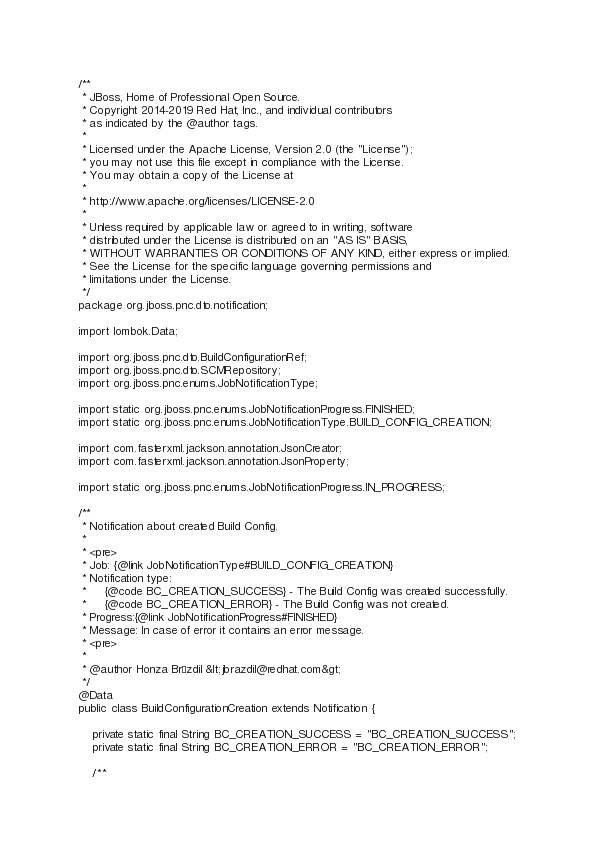Convert code to text. <code><loc_0><loc_0><loc_500><loc_500><_Java_>/**
 * JBoss, Home of Professional Open Source.
 * Copyright 2014-2019 Red Hat, Inc., and individual contributors
 * as indicated by the @author tags.
 *
 * Licensed under the Apache License, Version 2.0 (the "License");
 * you may not use this file except in compliance with the License.
 * You may obtain a copy of the License at
 *
 * http://www.apache.org/licenses/LICENSE-2.0
 *
 * Unless required by applicable law or agreed to in writing, software
 * distributed under the License is distributed on an "AS IS" BASIS,
 * WITHOUT WARRANTIES OR CONDITIONS OF ANY KIND, either express or implied.
 * See the License for the specific language governing permissions and
 * limitations under the License.
 */
package org.jboss.pnc.dto.notification;

import lombok.Data;

import org.jboss.pnc.dto.BuildConfigurationRef;
import org.jboss.pnc.dto.SCMRepository;
import org.jboss.pnc.enums.JobNotificationType;

import static org.jboss.pnc.enums.JobNotificationProgress.FINISHED;
import static org.jboss.pnc.enums.JobNotificationType.BUILD_CONFIG_CREATION;

import com.fasterxml.jackson.annotation.JsonCreator;
import com.fasterxml.jackson.annotation.JsonProperty;

import static org.jboss.pnc.enums.JobNotificationProgress.IN_PROGRESS;

/**
 * Notification about created Build Config.
 *   
 * <pre>
 * Job: {@link JobNotificationType#BUILD_CONFIG_CREATION}
 * Notification type:
 *     {@code BC_CREATION_SUCCESS} - The Build Config was created successfully.
 *     {@code BC_CREATION_ERROR} - The Build Config was not created.
 * Progress:{@link JobNotificationProgress#FINISHED}
 * Message: In case of error it contains an error message.
 * <pre>
 * 
 * @author Honza Brázdil &lt;jbrazdil@redhat.com&gt;
 */
@Data
public class BuildConfigurationCreation extends Notification {

    private static final String BC_CREATION_SUCCESS = "BC_CREATION_SUCCESS";
    private static final String BC_CREATION_ERROR = "BC_CREATION_ERROR";

    /**</code> 